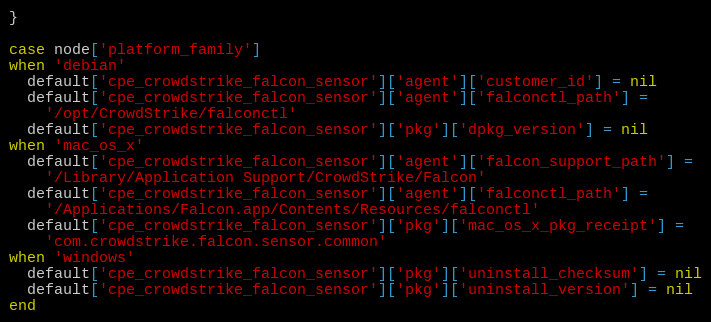Convert code to text. <code><loc_0><loc_0><loc_500><loc_500><_Ruby_>}

case node['platform_family']
when 'debian'
  default['cpe_crowdstrike_falcon_sensor']['agent']['customer_id'] = nil
  default['cpe_crowdstrike_falcon_sensor']['agent']['falconctl_path'] =
    '/opt/CrowdStrike/falconctl'
  default['cpe_crowdstrike_falcon_sensor']['pkg']['dpkg_version'] = nil
when 'mac_os_x'
  default['cpe_crowdstrike_falcon_sensor']['agent']['falcon_support_path'] =
    '/Library/Application Support/CrowdStrike/Falcon'
  default['cpe_crowdstrike_falcon_sensor']['agent']['falconctl_path'] =
    '/Applications/Falcon.app/Contents/Resources/falconctl'
  default['cpe_crowdstrike_falcon_sensor']['pkg']['mac_os_x_pkg_receipt'] =
    'com.crowdstrike.falcon.sensor.common'
when 'windows'
  default['cpe_crowdstrike_falcon_sensor']['pkg']['uninstall_checksum'] = nil
  default['cpe_crowdstrike_falcon_sensor']['pkg']['uninstall_version'] = nil
end
</code> 